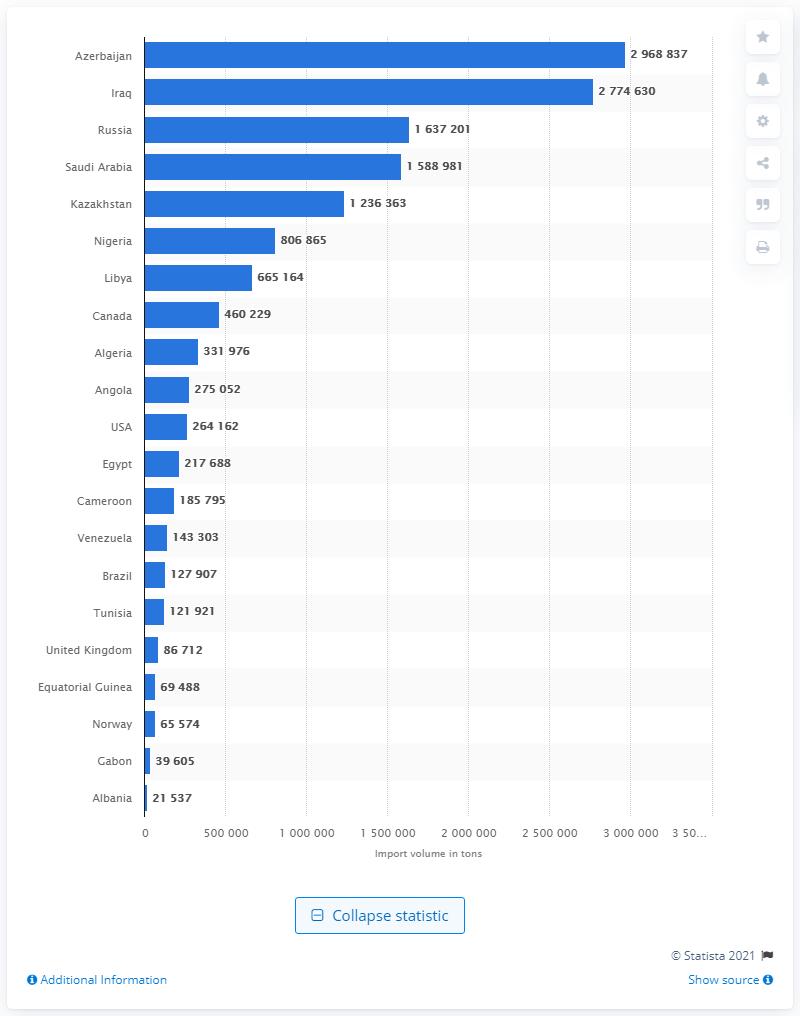Mention a couple of crucial points in this snapshot. In the first quarter of 2020, Iraq exported 277,463 tons of crude oil to Italy. 